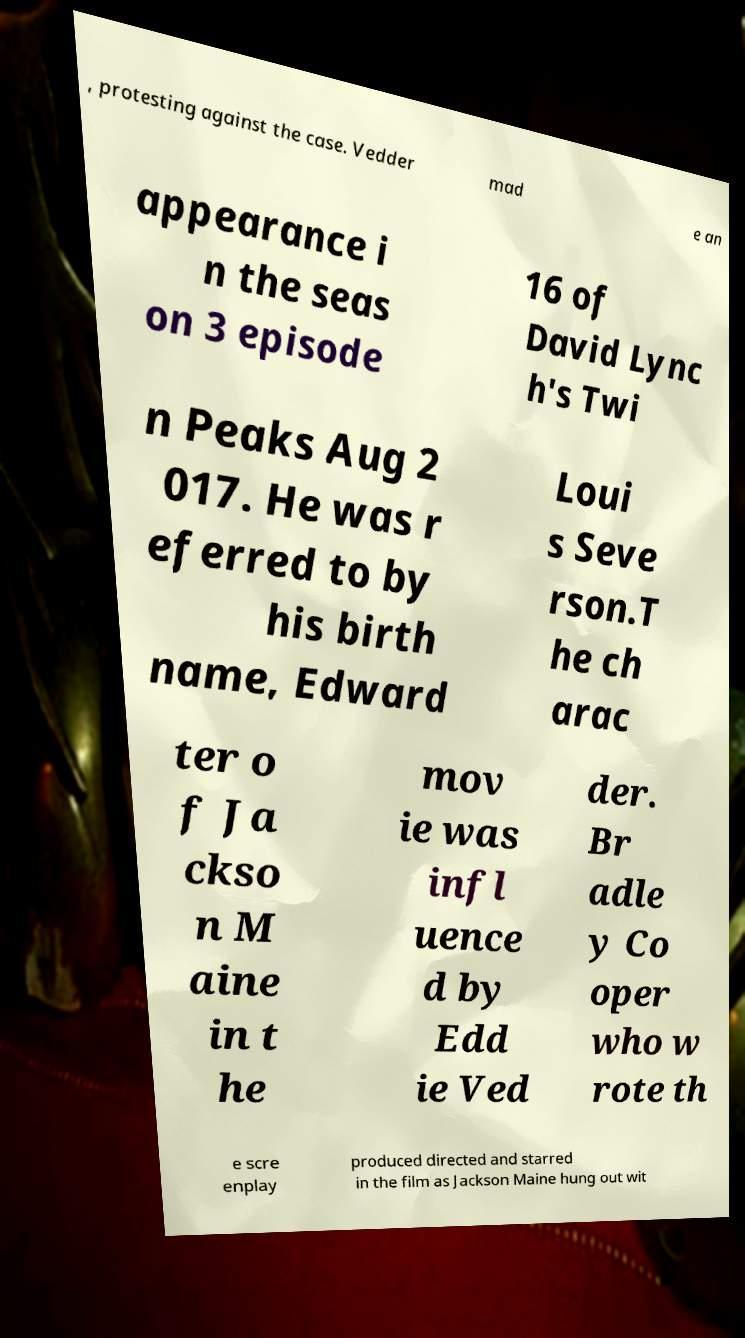Can you accurately transcribe the text from the provided image for me? , protesting against the case. Vedder mad e an appearance i n the seas on 3 episode 16 of David Lync h's Twi n Peaks Aug 2 017. He was r eferred to by his birth name, Edward Loui s Seve rson.T he ch arac ter o f Ja ckso n M aine in t he mov ie was infl uence d by Edd ie Ved der. Br adle y Co oper who w rote th e scre enplay produced directed and starred in the film as Jackson Maine hung out wit 